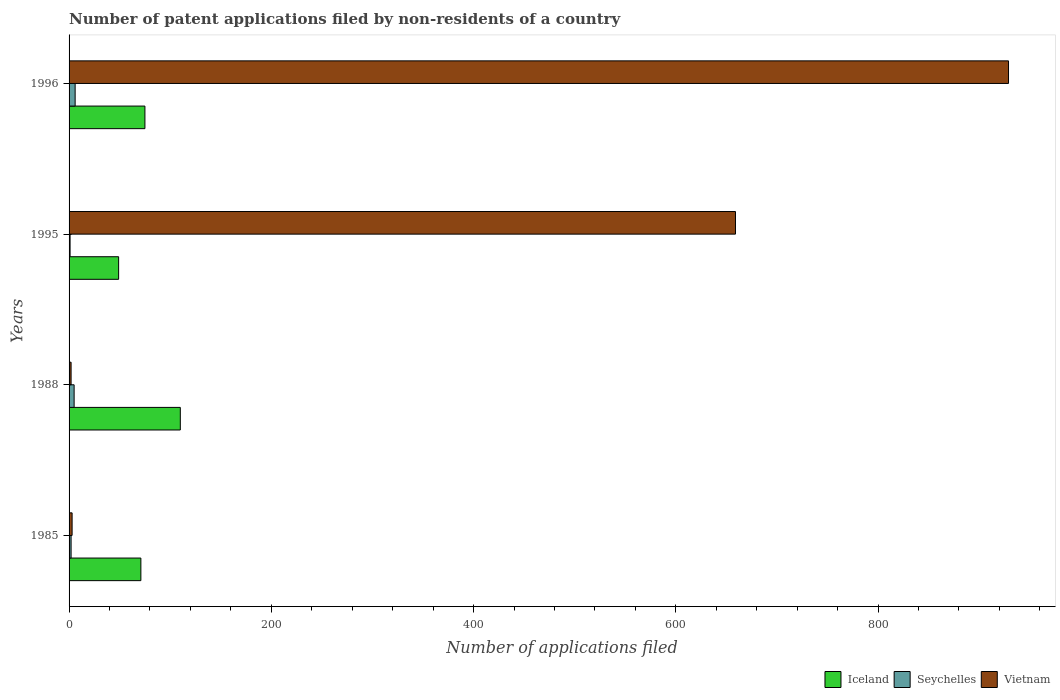Are the number of bars per tick equal to the number of legend labels?
Give a very brief answer. Yes. How many bars are there on the 3rd tick from the bottom?
Offer a very short reply. 3. What is the label of the 2nd group of bars from the top?
Your answer should be very brief. 1995. Across all years, what is the minimum number of applications filed in Seychelles?
Your response must be concise. 1. In which year was the number of applications filed in Vietnam minimum?
Give a very brief answer. 1988. What is the total number of applications filed in Iceland in the graph?
Keep it short and to the point. 305. What is the difference between the number of applications filed in Vietnam in 1996 and the number of applications filed in Seychelles in 1985?
Your response must be concise. 927. What is the average number of applications filed in Iceland per year?
Offer a very short reply. 76.25. In the year 1995, what is the difference between the number of applications filed in Seychelles and number of applications filed in Vietnam?
Your answer should be compact. -658. What is the ratio of the number of applications filed in Iceland in 1985 to that in 1988?
Make the answer very short. 0.65. Is the number of applications filed in Seychelles in 1988 less than that in 1996?
Keep it short and to the point. Yes. Is the difference between the number of applications filed in Seychelles in 1995 and 1996 greater than the difference between the number of applications filed in Vietnam in 1995 and 1996?
Provide a short and direct response. Yes. What is the difference between the highest and the second highest number of applications filed in Vietnam?
Make the answer very short. 270. What is the difference between the highest and the lowest number of applications filed in Iceland?
Offer a terse response. 61. In how many years, is the number of applications filed in Seychelles greater than the average number of applications filed in Seychelles taken over all years?
Offer a very short reply. 2. Is the sum of the number of applications filed in Vietnam in 1985 and 1995 greater than the maximum number of applications filed in Iceland across all years?
Offer a very short reply. Yes. What does the 1st bar from the top in 1996 represents?
Provide a succinct answer. Vietnam. What does the 2nd bar from the bottom in 1995 represents?
Keep it short and to the point. Seychelles. Are all the bars in the graph horizontal?
Ensure brevity in your answer.  Yes. What is the difference between two consecutive major ticks on the X-axis?
Give a very brief answer. 200. Are the values on the major ticks of X-axis written in scientific E-notation?
Your answer should be compact. No. Does the graph contain grids?
Offer a terse response. No. Where does the legend appear in the graph?
Your response must be concise. Bottom right. What is the title of the graph?
Provide a short and direct response. Number of patent applications filed by non-residents of a country. What is the label or title of the X-axis?
Your answer should be very brief. Number of applications filed. What is the label or title of the Y-axis?
Your answer should be very brief. Years. What is the Number of applications filed in Seychelles in 1985?
Make the answer very short. 2. What is the Number of applications filed of Iceland in 1988?
Your answer should be very brief. 110. What is the Number of applications filed in Vietnam in 1988?
Your response must be concise. 2. What is the Number of applications filed in Vietnam in 1995?
Offer a very short reply. 659. What is the Number of applications filed of Seychelles in 1996?
Give a very brief answer. 6. What is the Number of applications filed of Vietnam in 1996?
Ensure brevity in your answer.  929. Across all years, what is the maximum Number of applications filed of Iceland?
Your answer should be compact. 110. Across all years, what is the maximum Number of applications filed of Vietnam?
Your response must be concise. 929. Across all years, what is the minimum Number of applications filed of Iceland?
Your answer should be very brief. 49. Across all years, what is the minimum Number of applications filed of Seychelles?
Offer a very short reply. 1. What is the total Number of applications filed in Iceland in the graph?
Ensure brevity in your answer.  305. What is the total Number of applications filed in Vietnam in the graph?
Make the answer very short. 1593. What is the difference between the Number of applications filed in Iceland in 1985 and that in 1988?
Make the answer very short. -39. What is the difference between the Number of applications filed of Vietnam in 1985 and that in 1995?
Give a very brief answer. -656. What is the difference between the Number of applications filed of Iceland in 1985 and that in 1996?
Your answer should be compact. -4. What is the difference between the Number of applications filed of Vietnam in 1985 and that in 1996?
Give a very brief answer. -926. What is the difference between the Number of applications filed in Vietnam in 1988 and that in 1995?
Provide a succinct answer. -657. What is the difference between the Number of applications filed of Seychelles in 1988 and that in 1996?
Offer a terse response. -1. What is the difference between the Number of applications filed in Vietnam in 1988 and that in 1996?
Make the answer very short. -927. What is the difference between the Number of applications filed of Iceland in 1995 and that in 1996?
Your response must be concise. -26. What is the difference between the Number of applications filed of Vietnam in 1995 and that in 1996?
Keep it short and to the point. -270. What is the difference between the Number of applications filed of Iceland in 1985 and the Number of applications filed of Vietnam in 1988?
Offer a terse response. 69. What is the difference between the Number of applications filed of Seychelles in 1985 and the Number of applications filed of Vietnam in 1988?
Offer a terse response. 0. What is the difference between the Number of applications filed of Iceland in 1985 and the Number of applications filed of Seychelles in 1995?
Your response must be concise. 70. What is the difference between the Number of applications filed of Iceland in 1985 and the Number of applications filed of Vietnam in 1995?
Provide a succinct answer. -588. What is the difference between the Number of applications filed of Seychelles in 1985 and the Number of applications filed of Vietnam in 1995?
Your answer should be compact. -657. What is the difference between the Number of applications filed of Iceland in 1985 and the Number of applications filed of Vietnam in 1996?
Your response must be concise. -858. What is the difference between the Number of applications filed in Seychelles in 1985 and the Number of applications filed in Vietnam in 1996?
Ensure brevity in your answer.  -927. What is the difference between the Number of applications filed of Iceland in 1988 and the Number of applications filed of Seychelles in 1995?
Offer a terse response. 109. What is the difference between the Number of applications filed of Iceland in 1988 and the Number of applications filed of Vietnam in 1995?
Ensure brevity in your answer.  -549. What is the difference between the Number of applications filed of Seychelles in 1988 and the Number of applications filed of Vietnam in 1995?
Give a very brief answer. -654. What is the difference between the Number of applications filed of Iceland in 1988 and the Number of applications filed of Seychelles in 1996?
Keep it short and to the point. 104. What is the difference between the Number of applications filed of Iceland in 1988 and the Number of applications filed of Vietnam in 1996?
Ensure brevity in your answer.  -819. What is the difference between the Number of applications filed in Seychelles in 1988 and the Number of applications filed in Vietnam in 1996?
Your answer should be very brief. -924. What is the difference between the Number of applications filed of Iceland in 1995 and the Number of applications filed of Seychelles in 1996?
Ensure brevity in your answer.  43. What is the difference between the Number of applications filed of Iceland in 1995 and the Number of applications filed of Vietnam in 1996?
Make the answer very short. -880. What is the difference between the Number of applications filed of Seychelles in 1995 and the Number of applications filed of Vietnam in 1996?
Provide a short and direct response. -928. What is the average Number of applications filed of Iceland per year?
Your answer should be compact. 76.25. What is the average Number of applications filed in Seychelles per year?
Make the answer very short. 3.5. What is the average Number of applications filed of Vietnam per year?
Ensure brevity in your answer.  398.25. In the year 1985, what is the difference between the Number of applications filed in Iceland and Number of applications filed in Vietnam?
Ensure brevity in your answer.  68. In the year 1985, what is the difference between the Number of applications filed in Seychelles and Number of applications filed in Vietnam?
Provide a short and direct response. -1. In the year 1988, what is the difference between the Number of applications filed in Iceland and Number of applications filed in Seychelles?
Provide a short and direct response. 105. In the year 1988, what is the difference between the Number of applications filed in Iceland and Number of applications filed in Vietnam?
Your answer should be very brief. 108. In the year 1995, what is the difference between the Number of applications filed in Iceland and Number of applications filed in Vietnam?
Make the answer very short. -610. In the year 1995, what is the difference between the Number of applications filed of Seychelles and Number of applications filed of Vietnam?
Your answer should be very brief. -658. In the year 1996, what is the difference between the Number of applications filed of Iceland and Number of applications filed of Seychelles?
Make the answer very short. 69. In the year 1996, what is the difference between the Number of applications filed of Iceland and Number of applications filed of Vietnam?
Provide a succinct answer. -854. In the year 1996, what is the difference between the Number of applications filed in Seychelles and Number of applications filed in Vietnam?
Offer a terse response. -923. What is the ratio of the Number of applications filed in Iceland in 1985 to that in 1988?
Offer a terse response. 0.65. What is the ratio of the Number of applications filed in Seychelles in 1985 to that in 1988?
Offer a terse response. 0.4. What is the ratio of the Number of applications filed in Vietnam in 1985 to that in 1988?
Your answer should be compact. 1.5. What is the ratio of the Number of applications filed in Iceland in 1985 to that in 1995?
Your answer should be compact. 1.45. What is the ratio of the Number of applications filed in Seychelles in 1985 to that in 1995?
Your answer should be compact. 2. What is the ratio of the Number of applications filed in Vietnam in 1985 to that in 1995?
Keep it short and to the point. 0. What is the ratio of the Number of applications filed of Iceland in 1985 to that in 1996?
Offer a very short reply. 0.95. What is the ratio of the Number of applications filed in Vietnam in 1985 to that in 1996?
Offer a very short reply. 0. What is the ratio of the Number of applications filed of Iceland in 1988 to that in 1995?
Your answer should be very brief. 2.24. What is the ratio of the Number of applications filed of Seychelles in 1988 to that in 1995?
Give a very brief answer. 5. What is the ratio of the Number of applications filed of Vietnam in 1988 to that in 1995?
Your response must be concise. 0. What is the ratio of the Number of applications filed of Iceland in 1988 to that in 1996?
Your answer should be very brief. 1.47. What is the ratio of the Number of applications filed in Vietnam in 1988 to that in 1996?
Your answer should be compact. 0. What is the ratio of the Number of applications filed of Iceland in 1995 to that in 1996?
Give a very brief answer. 0.65. What is the ratio of the Number of applications filed in Vietnam in 1995 to that in 1996?
Your answer should be very brief. 0.71. What is the difference between the highest and the second highest Number of applications filed of Vietnam?
Offer a very short reply. 270. What is the difference between the highest and the lowest Number of applications filed in Vietnam?
Your answer should be compact. 927. 